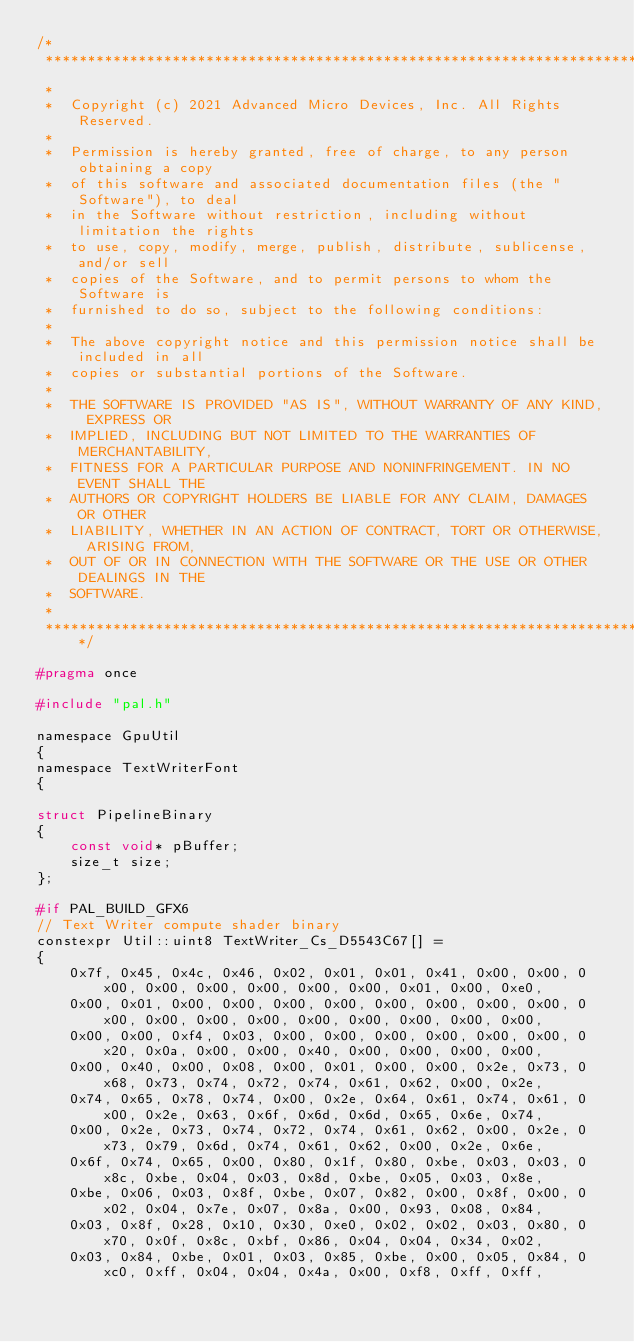<code> <loc_0><loc_0><loc_500><loc_500><_C_>/*
 ***********************************************************************************************************************
 *
 *  Copyright (c) 2021 Advanced Micro Devices, Inc. All Rights Reserved.
 *
 *  Permission is hereby granted, free of charge, to any person obtaining a copy
 *  of this software and associated documentation files (the "Software"), to deal
 *  in the Software without restriction, including without limitation the rights
 *  to use, copy, modify, merge, publish, distribute, sublicense, and/or sell
 *  copies of the Software, and to permit persons to whom the Software is
 *  furnished to do so, subject to the following conditions:
 *
 *  The above copyright notice and this permission notice shall be included in all
 *  copies or substantial portions of the Software.
 *
 *  THE SOFTWARE IS PROVIDED "AS IS", WITHOUT WARRANTY OF ANY KIND, EXPRESS OR
 *  IMPLIED, INCLUDING BUT NOT LIMITED TO THE WARRANTIES OF MERCHANTABILITY,
 *  FITNESS FOR A PARTICULAR PURPOSE AND NONINFRINGEMENT. IN NO EVENT SHALL THE
 *  AUTHORS OR COPYRIGHT HOLDERS BE LIABLE FOR ANY CLAIM, DAMAGES OR OTHER
 *  LIABILITY, WHETHER IN AN ACTION OF CONTRACT, TORT OR OTHERWISE, ARISING FROM,
 *  OUT OF OR IN CONNECTION WITH THE SOFTWARE OR THE USE OR OTHER DEALINGS IN THE
 *  SOFTWARE.
 *
 **********************************************************************************************************************/

#pragma once

#include "pal.h"

namespace GpuUtil
{
namespace TextWriterFont
{

struct PipelineBinary
{
    const void* pBuffer;
    size_t size;
};

#if PAL_BUILD_GFX6
// Text Writer compute shader binary
constexpr Util::uint8 TextWriter_Cs_D5543C67[] =
{
    0x7f, 0x45, 0x4c, 0x46, 0x02, 0x01, 0x01, 0x41, 0x00, 0x00, 0x00, 0x00, 0x00, 0x00, 0x00, 0x00, 0x01, 0x00, 0xe0,
    0x00, 0x01, 0x00, 0x00, 0x00, 0x00, 0x00, 0x00, 0x00, 0x00, 0x00, 0x00, 0x00, 0x00, 0x00, 0x00, 0x00, 0x00, 0x00,
    0x00, 0x00, 0xf4, 0x03, 0x00, 0x00, 0x00, 0x00, 0x00, 0x00, 0x20, 0x0a, 0x00, 0x00, 0x40, 0x00, 0x00, 0x00, 0x00,
    0x00, 0x40, 0x00, 0x08, 0x00, 0x01, 0x00, 0x00, 0x2e, 0x73, 0x68, 0x73, 0x74, 0x72, 0x74, 0x61, 0x62, 0x00, 0x2e,
    0x74, 0x65, 0x78, 0x74, 0x00, 0x2e, 0x64, 0x61, 0x74, 0x61, 0x00, 0x2e, 0x63, 0x6f, 0x6d, 0x6d, 0x65, 0x6e, 0x74,
    0x00, 0x2e, 0x73, 0x74, 0x72, 0x74, 0x61, 0x62, 0x00, 0x2e, 0x73, 0x79, 0x6d, 0x74, 0x61, 0x62, 0x00, 0x2e, 0x6e,
    0x6f, 0x74, 0x65, 0x00, 0x80, 0x1f, 0x80, 0xbe, 0x03, 0x03, 0x8c, 0xbe, 0x04, 0x03, 0x8d, 0xbe, 0x05, 0x03, 0x8e,
    0xbe, 0x06, 0x03, 0x8f, 0xbe, 0x07, 0x82, 0x00, 0x8f, 0x00, 0x02, 0x04, 0x7e, 0x07, 0x8a, 0x00, 0x93, 0x08, 0x84,
    0x03, 0x8f, 0x28, 0x10, 0x30, 0xe0, 0x02, 0x02, 0x03, 0x80, 0x70, 0x0f, 0x8c, 0xbf, 0x86, 0x04, 0x04, 0x34, 0x02,
    0x03, 0x84, 0xbe, 0x01, 0x03, 0x85, 0xbe, 0x00, 0x05, 0x84, 0xc0, 0xff, 0x04, 0x04, 0x4a, 0x00, 0xf8, 0xff, 0xff,</code> 